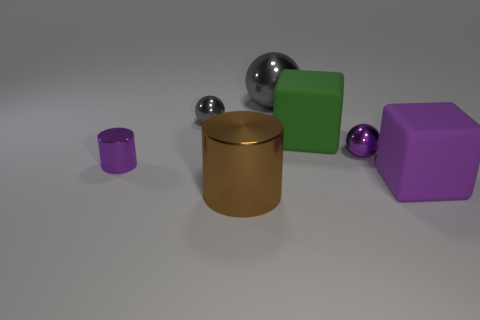There is a block in front of the green matte cube; does it have the same size as the gray shiny ball on the right side of the brown metallic object?
Provide a short and direct response. Yes. How many blocks are small purple matte things or purple rubber objects?
Give a very brief answer. 1. Are the small object to the right of the green thing and the big brown cylinder made of the same material?
Provide a succinct answer. Yes. How many other things are there of the same size as the green rubber object?
Your answer should be very brief. 3. What number of big things are purple cylinders or red cubes?
Provide a succinct answer. 0. Is the color of the large ball the same as the small metallic cylinder?
Offer a very short reply. No. Are there more big purple matte blocks that are behind the green matte thing than brown metal cylinders on the right side of the big gray ball?
Provide a succinct answer. No. Does the tiny ball that is right of the large brown shiny object have the same color as the tiny cylinder?
Offer a very short reply. Yes. Is there anything else of the same color as the big shiny cylinder?
Give a very brief answer. No. Is the number of small gray spheres in front of the purple shiny ball greater than the number of tiny red spheres?
Provide a succinct answer. No. 